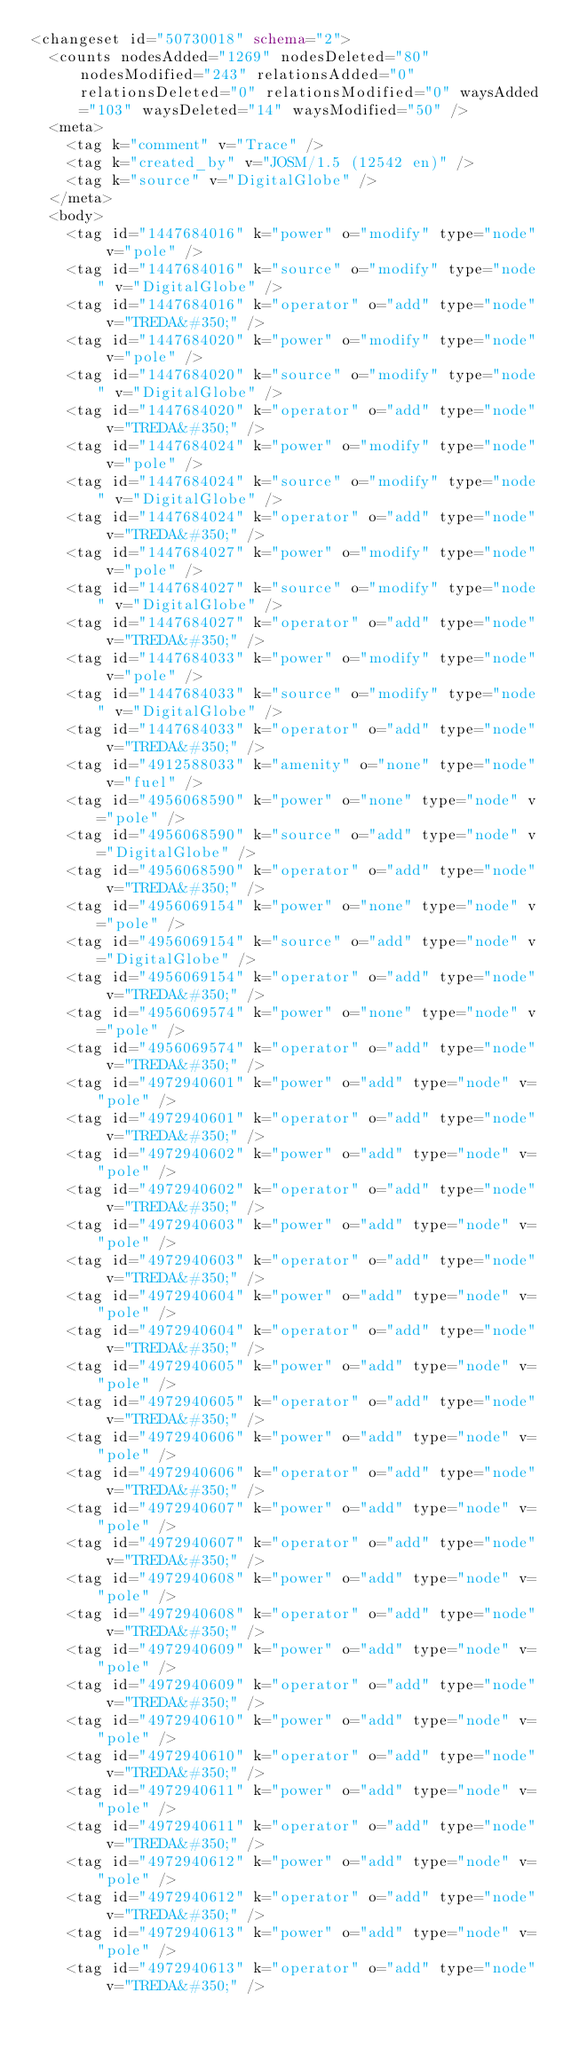Convert code to text. <code><loc_0><loc_0><loc_500><loc_500><_XML_><changeset id="50730018" schema="2">
  <counts nodesAdded="1269" nodesDeleted="80" nodesModified="243" relationsAdded="0" relationsDeleted="0" relationsModified="0" waysAdded="103" waysDeleted="14" waysModified="50" />
  <meta>
    <tag k="comment" v="Trace" />
    <tag k="created_by" v="JOSM/1.5 (12542 en)" />
    <tag k="source" v="DigitalGlobe" />
  </meta>
  <body>
    <tag id="1447684016" k="power" o="modify" type="node" v="pole" />
    <tag id="1447684016" k="source" o="modify" type="node" v="DigitalGlobe" />
    <tag id="1447684016" k="operator" o="add" type="node" v="TREDA&#350;" />
    <tag id="1447684020" k="power" o="modify" type="node" v="pole" />
    <tag id="1447684020" k="source" o="modify" type="node" v="DigitalGlobe" />
    <tag id="1447684020" k="operator" o="add" type="node" v="TREDA&#350;" />
    <tag id="1447684024" k="power" o="modify" type="node" v="pole" />
    <tag id="1447684024" k="source" o="modify" type="node" v="DigitalGlobe" />
    <tag id="1447684024" k="operator" o="add" type="node" v="TREDA&#350;" />
    <tag id="1447684027" k="power" o="modify" type="node" v="pole" />
    <tag id="1447684027" k="source" o="modify" type="node" v="DigitalGlobe" />
    <tag id="1447684027" k="operator" o="add" type="node" v="TREDA&#350;" />
    <tag id="1447684033" k="power" o="modify" type="node" v="pole" />
    <tag id="1447684033" k="source" o="modify" type="node" v="DigitalGlobe" />
    <tag id="1447684033" k="operator" o="add" type="node" v="TREDA&#350;" />
    <tag id="4912588033" k="amenity" o="none" type="node" v="fuel" />
    <tag id="4956068590" k="power" o="none" type="node" v="pole" />
    <tag id="4956068590" k="source" o="add" type="node" v="DigitalGlobe" />
    <tag id="4956068590" k="operator" o="add" type="node" v="TREDA&#350;" />
    <tag id="4956069154" k="power" o="none" type="node" v="pole" />
    <tag id="4956069154" k="source" o="add" type="node" v="DigitalGlobe" />
    <tag id="4956069154" k="operator" o="add" type="node" v="TREDA&#350;" />
    <tag id="4956069574" k="power" o="none" type="node" v="pole" />
    <tag id="4956069574" k="operator" o="add" type="node" v="TREDA&#350;" />
    <tag id="4972940601" k="power" o="add" type="node" v="pole" />
    <tag id="4972940601" k="operator" o="add" type="node" v="TREDA&#350;" />
    <tag id="4972940602" k="power" o="add" type="node" v="pole" />
    <tag id="4972940602" k="operator" o="add" type="node" v="TREDA&#350;" />
    <tag id="4972940603" k="power" o="add" type="node" v="pole" />
    <tag id="4972940603" k="operator" o="add" type="node" v="TREDA&#350;" />
    <tag id="4972940604" k="power" o="add" type="node" v="pole" />
    <tag id="4972940604" k="operator" o="add" type="node" v="TREDA&#350;" />
    <tag id="4972940605" k="power" o="add" type="node" v="pole" />
    <tag id="4972940605" k="operator" o="add" type="node" v="TREDA&#350;" />
    <tag id="4972940606" k="power" o="add" type="node" v="pole" />
    <tag id="4972940606" k="operator" o="add" type="node" v="TREDA&#350;" />
    <tag id="4972940607" k="power" o="add" type="node" v="pole" />
    <tag id="4972940607" k="operator" o="add" type="node" v="TREDA&#350;" />
    <tag id="4972940608" k="power" o="add" type="node" v="pole" />
    <tag id="4972940608" k="operator" o="add" type="node" v="TREDA&#350;" />
    <tag id="4972940609" k="power" o="add" type="node" v="pole" />
    <tag id="4972940609" k="operator" o="add" type="node" v="TREDA&#350;" />
    <tag id="4972940610" k="power" o="add" type="node" v="pole" />
    <tag id="4972940610" k="operator" o="add" type="node" v="TREDA&#350;" />
    <tag id="4972940611" k="power" o="add" type="node" v="pole" />
    <tag id="4972940611" k="operator" o="add" type="node" v="TREDA&#350;" />
    <tag id="4972940612" k="power" o="add" type="node" v="pole" />
    <tag id="4972940612" k="operator" o="add" type="node" v="TREDA&#350;" />
    <tag id="4972940613" k="power" o="add" type="node" v="pole" />
    <tag id="4972940613" k="operator" o="add" type="node" v="TREDA&#350;" /></code> 